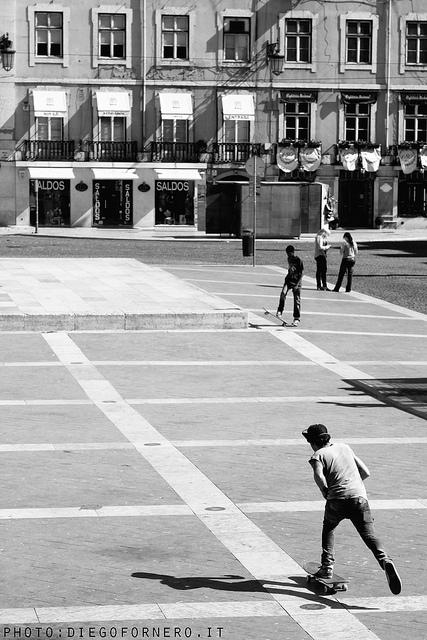How many windows are there?
Concise answer only. 14. Are there fonts in this picture?
Give a very brief answer. Yes. What are the men riding?
Answer briefly. Skateboards. 